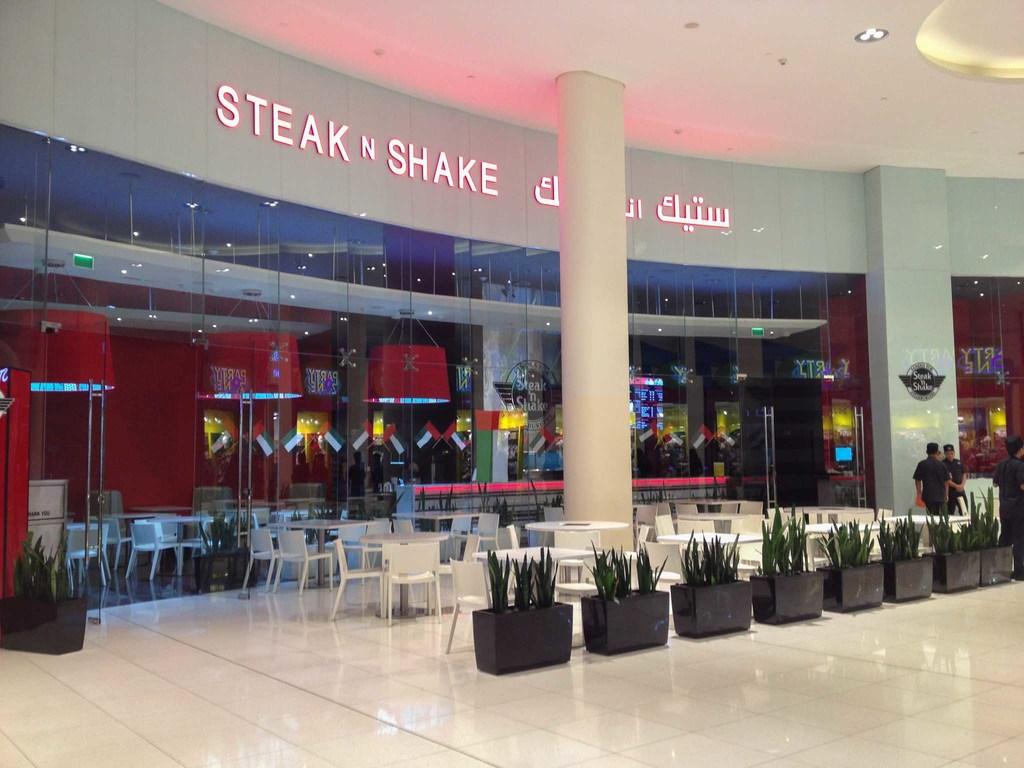What restaurant is displayed?
Your answer should be compact. Steak n shake. 